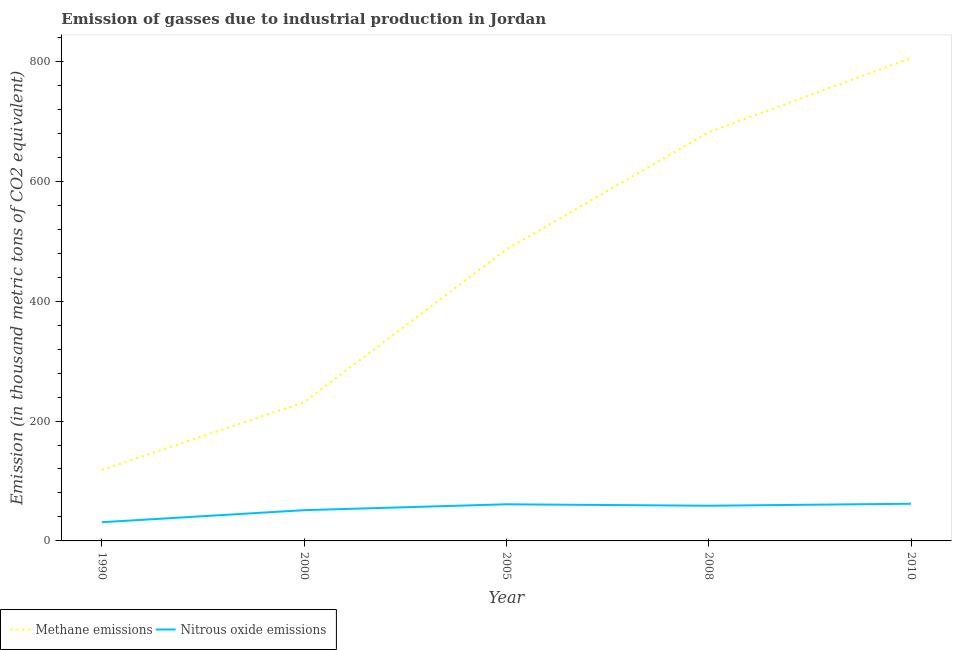What is the amount of methane emissions in 2008?
Ensure brevity in your answer.  681.7. Across all years, what is the maximum amount of nitrous oxide emissions?
Your response must be concise. 62. Across all years, what is the minimum amount of methane emissions?
Make the answer very short. 118.4. In which year was the amount of methane emissions maximum?
Provide a succinct answer. 2010. What is the total amount of methane emissions in the graph?
Ensure brevity in your answer.  2323.2. What is the difference between the amount of methane emissions in 2000 and that in 2005?
Provide a succinct answer. -254.9. What is the difference between the amount of nitrous oxide emissions in 2010 and the amount of methane emissions in 1990?
Your response must be concise. -56.4. What is the average amount of methane emissions per year?
Give a very brief answer. 464.64. In the year 2005, what is the difference between the amount of methane emissions and amount of nitrous oxide emissions?
Your answer should be compact. 425.2. In how many years, is the amount of methane emissions greater than 200 thousand metric tons?
Give a very brief answer. 4. What is the ratio of the amount of methane emissions in 1990 to that in 2005?
Provide a short and direct response. 0.24. Is the difference between the amount of methane emissions in 2000 and 2008 greater than the difference between the amount of nitrous oxide emissions in 2000 and 2008?
Offer a terse response. No. What is the difference between the highest and the second highest amount of nitrous oxide emissions?
Keep it short and to the point. 0.9. What is the difference between the highest and the lowest amount of nitrous oxide emissions?
Provide a succinct answer. 30.8. In how many years, is the amount of methane emissions greater than the average amount of methane emissions taken over all years?
Your response must be concise. 3. Is the sum of the amount of methane emissions in 2000 and 2005 greater than the maximum amount of nitrous oxide emissions across all years?
Give a very brief answer. Yes. Does the amount of methane emissions monotonically increase over the years?
Provide a succinct answer. Yes. Is the amount of methane emissions strictly greater than the amount of nitrous oxide emissions over the years?
Your answer should be very brief. Yes. How many lines are there?
Your answer should be compact. 2. What is the difference between two consecutive major ticks on the Y-axis?
Provide a succinct answer. 200. Are the values on the major ticks of Y-axis written in scientific E-notation?
Your answer should be very brief. No. Does the graph contain any zero values?
Give a very brief answer. No. Where does the legend appear in the graph?
Provide a succinct answer. Bottom left. How many legend labels are there?
Keep it short and to the point. 2. What is the title of the graph?
Your answer should be compact. Emission of gasses due to industrial production in Jordan. What is the label or title of the X-axis?
Your response must be concise. Year. What is the label or title of the Y-axis?
Provide a succinct answer. Emission (in thousand metric tons of CO2 equivalent). What is the Emission (in thousand metric tons of CO2 equivalent) in Methane emissions in 1990?
Offer a terse response. 118.4. What is the Emission (in thousand metric tons of CO2 equivalent) in Nitrous oxide emissions in 1990?
Your response must be concise. 31.2. What is the Emission (in thousand metric tons of CO2 equivalent) in Methane emissions in 2000?
Your answer should be compact. 231.4. What is the Emission (in thousand metric tons of CO2 equivalent) in Nitrous oxide emissions in 2000?
Offer a very short reply. 51.3. What is the Emission (in thousand metric tons of CO2 equivalent) of Methane emissions in 2005?
Ensure brevity in your answer.  486.3. What is the Emission (in thousand metric tons of CO2 equivalent) of Nitrous oxide emissions in 2005?
Make the answer very short. 61.1. What is the Emission (in thousand metric tons of CO2 equivalent) of Methane emissions in 2008?
Your answer should be very brief. 681.7. What is the Emission (in thousand metric tons of CO2 equivalent) of Nitrous oxide emissions in 2008?
Provide a short and direct response. 58.7. What is the Emission (in thousand metric tons of CO2 equivalent) in Methane emissions in 2010?
Your answer should be very brief. 805.4. What is the Emission (in thousand metric tons of CO2 equivalent) in Nitrous oxide emissions in 2010?
Your answer should be compact. 62. Across all years, what is the maximum Emission (in thousand metric tons of CO2 equivalent) of Methane emissions?
Provide a succinct answer. 805.4. Across all years, what is the maximum Emission (in thousand metric tons of CO2 equivalent) of Nitrous oxide emissions?
Make the answer very short. 62. Across all years, what is the minimum Emission (in thousand metric tons of CO2 equivalent) of Methane emissions?
Your response must be concise. 118.4. Across all years, what is the minimum Emission (in thousand metric tons of CO2 equivalent) of Nitrous oxide emissions?
Provide a succinct answer. 31.2. What is the total Emission (in thousand metric tons of CO2 equivalent) in Methane emissions in the graph?
Your response must be concise. 2323.2. What is the total Emission (in thousand metric tons of CO2 equivalent) in Nitrous oxide emissions in the graph?
Your answer should be compact. 264.3. What is the difference between the Emission (in thousand metric tons of CO2 equivalent) in Methane emissions in 1990 and that in 2000?
Your answer should be very brief. -113. What is the difference between the Emission (in thousand metric tons of CO2 equivalent) in Nitrous oxide emissions in 1990 and that in 2000?
Make the answer very short. -20.1. What is the difference between the Emission (in thousand metric tons of CO2 equivalent) of Methane emissions in 1990 and that in 2005?
Offer a terse response. -367.9. What is the difference between the Emission (in thousand metric tons of CO2 equivalent) in Nitrous oxide emissions in 1990 and that in 2005?
Offer a terse response. -29.9. What is the difference between the Emission (in thousand metric tons of CO2 equivalent) in Methane emissions in 1990 and that in 2008?
Your answer should be compact. -563.3. What is the difference between the Emission (in thousand metric tons of CO2 equivalent) in Nitrous oxide emissions in 1990 and that in 2008?
Keep it short and to the point. -27.5. What is the difference between the Emission (in thousand metric tons of CO2 equivalent) in Methane emissions in 1990 and that in 2010?
Ensure brevity in your answer.  -687. What is the difference between the Emission (in thousand metric tons of CO2 equivalent) of Nitrous oxide emissions in 1990 and that in 2010?
Offer a terse response. -30.8. What is the difference between the Emission (in thousand metric tons of CO2 equivalent) of Methane emissions in 2000 and that in 2005?
Offer a very short reply. -254.9. What is the difference between the Emission (in thousand metric tons of CO2 equivalent) of Nitrous oxide emissions in 2000 and that in 2005?
Your answer should be compact. -9.8. What is the difference between the Emission (in thousand metric tons of CO2 equivalent) of Methane emissions in 2000 and that in 2008?
Provide a short and direct response. -450.3. What is the difference between the Emission (in thousand metric tons of CO2 equivalent) of Methane emissions in 2000 and that in 2010?
Offer a terse response. -574. What is the difference between the Emission (in thousand metric tons of CO2 equivalent) of Nitrous oxide emissions in 2000 and that in 2010?
Provide a short and direct response. -10.7. What is the difference between the Emission (in thousand metric tons of CO2 equivalent) in Methane emissions in 2005 and that in 2008?
Make the answer very short. -195.4. What is the difference between the Emission (in thousand metric tons of CO2 equivalent) in Nitrous oxide emissions in 2005 and that in 2008?
Your response must be concise. 2.4. What is the difference between the Emission (in thousand metric tons of CO2 equivalent) of Methane emissions in 2005 and that in 2010?
Your response must be concise. -319.1. What is the difference between the Emission (in thousand metric tons of CO2 equivalent) in Nitrous oxide emissions in 2005 and that in 2010?
Keep it short and to the point. -0.9. What is the difference between the Emission (in thousand metric tons of CO2 equivalent) of Methane emissions in 2008 and that in 2010?
Ensure brevity in your answer.  -123.7. What is the difference between the Emission (in thousand metric tons of CO2 equivalent) of Methane emissions in 1990 and the Emission (in thousand metric tons of CO2 equivalent) of Nitrous oxide emissions in 2000?
Your response must be concise. 67.1. What is the difference between the Emission (in thousand metric tons of CO2 equivalent) in Methane emissions in 1990 and the Emission (in thousand metric tons of CO2 equivalent) in Nitrous oxide emissions in 2005?
Your response must be concise. 57.3. What is the difference between the Emission (in thousand metric tons of CO2 equivalent) of Methane emissions in 1990 and the Emission (in thousand metric tons of CO2 equivalent) of Nitrous oxide emissions in 2008?
Your answer should be very brief. 59.7. What is the difference between the Emission (in thousand metric tons of CO2 equivalent) in Methane emissions in 1990 and the Emission (in thousand metric tons of CO2 equivalent) in Nitrous oxide emissions in 2010?
Your response must be concise. 56.4. What is the difference between the Emission (in thousand metric tons of CO2 equivalent) in Methane emissions in 2000 and the Emission (in thousand metric tons of CO2 equivalent) in Nitrous oxide emissions in 2005?
Provide a short and direct response. 170.3. What is the difference between the Emission (in thousand metric tons of CO2 equivalent) of Methane emissions in 2000 and the Emission (in thousand metric tons of CO2 equivalent) of Nitrous oxide emissions in 2008?
Your answer should be very brief. 172.7. What is the difference between the Emission (in thousand metric tons of CO2 equivalent) in Methane emissions in 2000 and the Emission (in thousand metric tons of CO2 equivalent) in Nitrous oxide emissions in 2010?
Ensure brevity in your answer.  169.4. What is the difference between the Emission (in thousand metric tons of CO2 equivalent) in Methane emissions in 2005 and the Emission (in thousand metric tons of CO2 equivalent) in Nitrous oxide emissions in 2008?
Provide a short and direct response. 427.6. What is the difference between the Emission (in thousand metric tons of CO2 equivalent) in Methane emissions in 2005 and the Emission (in thousand metric tons of CO2 equivalent) in Nitrous oxide emissions in 2010?
Your answer should be compact. 424.3. What is the difference between the Emission (in thousand metric tons of CO2 equivalent) in Methane emissions in 2008 and the Emission (in thousand metric tons of CO2 equivalent) in Nitrous oxide emissions in 2010?
Ensure brevity in your answer.  619.7. What is the average Emission (in thousand metric tons of CO2 equivalent) in Methane emissions per year?
Give a very brief answer. 464.64. What is the average Emission (in thousand metric tons of CO2 equivalent) in Nitrous oxide emissions per year?
Ensure brevity in your answer.  52.86. In the year 1990, what is the difference between the Emission (in thousand metric tons of CO2 equivalent) in Methane emissions and Emission (in thousand metric tons of CO2 equivalent) in Nitrous oxide emissions?
Keep it short and to the point. 87.2. In the year 2000, what is the difference between the Emission (in thousand metric tons of CO2 equivalent) in Methane emissions and Emission (in thousand metric tons of CO2 equivalent) in Nitrous oxide emissions?
Your response must be concise. 180.1. In the year 2005, what is the difference between the Emission (in thousand metric tons of CO2 equivalent) in Methane emissions and Emission (in thousand metric tons of CO2 equivalent) in Nitrous oxide emissions?
Your answer should be very brief. 425.2. In the year 2008, what is the difference between the Emission (in thousand metric tons of CO2 equivalent) of Methane emissions and Emission (in thousand metric tons of CO2 equivalent) of Nitrous oxide emissions?
Keep it short and to the point. 623. In the year 2010, what is the difference between the Emission (in thousand metric tons of CO2 equivalent) of Methane emissions and Emission (in thousand metric tons of CO2 equivalent) of Nitrous oxide emissions?
Offer a terse response. 743.4. What is the ratio of the Emission (in thousand metric tons of CO2 equivalent) of Methane emissions in 1990 to that in 2000?
Your answer should be very brief. 0.51. What is the ratio of the Emission (in thousand metric tons of CO2 equivalent) of Nitrous oxide emissions in 1990 to that in 2000?
Your answer should be very brief. 0.61. What is the ratio of the Emission (in thousand metric tons of CO2 equivalent) in Methane emissions in 1990 to that in 2005?
Offer a very short reply. 0.24. What is the ratio of the Emission (in thousand metric tons of CO2 equivalent) of Nitrous oxide emissions in 1990 to that in 2005?
Your response must be concise. 0.51. What is the ratio of the Emission (in thousand metric tons of CO2 equivalent) of Methane emissions in 1990 to that in 2008?
Provide a succinct answer. 0.17. What is the ratio of the Emission (in thousand metric tons of CO2 equivalent) of Nitrous oxide emissions in 1990 to that in 2008?
Your answer should be compact. 0.53. What is the ratio of the Emission (in thousand metric tons of CO2 equivalent) of Methane emissions in 1990 to that in 2010?
Provide a succinct answer. 0.15. What is the ratio of the Emission (in thousand metric tons of CO2 equivalent) in Nitrous oxide emissions in 1990 to that in 2010?
Your response must be concise. 0.5. What is the ratio of the Emission (in thousand metric tons of CO2 equivalent) in Methane emissions in 2000 to that in 2005?
Provide a succinct answer. 0.48. What is the ratio of the Emission (in thousand metric tons of CO2 equivalent) in Nitrous oxide emissions in 2000 to that in 2005?
Your response must be concise. 0.84. What is the ratio of the Emission (in thousand metric tons of CO2 equivalent) in Methane emissions in 2000 to that in 2008?
Keep it short and to the point. 0.34. What is the ratio of the Emission (in thousand metric tons of CO2 equivalent) of Nitrous oxide emissions in 2000 to that in 2008?
Provide a short and direct response. 0.87. What is the ratio of the Emission (in thousand metric tons of CO2 equivalent) in Methane emissions in 2000 to that in 2010?
Provide a succinct answer. 0.29. What is the ratio of the Emission (in thousand metric tons of CO2 equivalent) of Nitrous oxide emissions in 2000 to that in 2010?
Provide a succinct answer. 0.83. What is the ratio of the Emission (in thousand metric tons of CO2 equivalent) of Methane emissions in 2005 to that in 2008?
Offer a very short reply. 0.71. What is the ratio of the Emission (in thousand metric tons of CO2 equivalent) of Nitrous oxide emissions in 2005 to that in 2008?
Keep it short and to the point. 1.04. What is the ratio of the Emission (in thousand metric tons of CO2 equivalent) in Methane emissions in 2005 to that in 2010?
Offer a terse response. 0.6. What is the ratio of the Emission (in thousand metric tons of CO2 equivalent) of Nitrous oxide emissions in 2005 to that in 2010?
Your answer should be compact. 0.99. What is the ratio of the Emission (in thousand metric tons of CO2 equivalent) of Methane emissions in 2008 to that in 2010?
Offer a terse response. 0.85. What is the ratio of the Emission (in thousand metric tons of CO2 equivalent) of Nitrous oxide emissions in 2008 to that in 2010?
Ensure brevity in your answer.  0.95. What is the difference between the highest and the second highest Emission (in thousand metric tons of CO2 equivalent) in Methane emissions?
Provide a succinct answer. 123.7. What is the difference between the highest and the second highest Emission (in thousand metric tons of CO2 equivalent) of Nitrous oxide emissions?
Provide a succinct answer. 0.9. What is the difference between the highest and the lowest Emission (in thousand metric tons of CO2 equivalent) in Methane emissions?
Make the answer very short. 687. What is the difference between the highest and the lowest Emission (in thousand metric tons of CO2 equivalent) in Nitrous oxide emissions?
Keep it short and to the point. 30.8. 